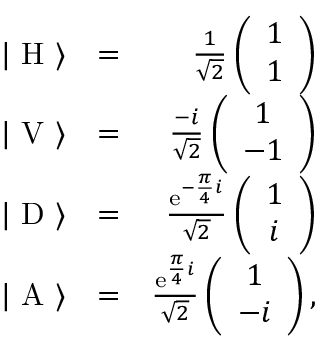Convert formula to latex. <formula><loc_0><loc_0><loc_500><loc_500>\begin{array} { r l r } { | \ H \ \rangle } & { = } & { \frac { 1 } { \sqrt { 2 } } \left ( \begin{array} { c } { 1 } \\ { 1 } \end{array} \right ) } \\ { | \ V \ \rangle } & { = } & { \frac { - i } { \sqrt { 2 } } \left ( \begin{array} { c } { 1 } \\ { - 1 } \end{array} \right ) } \\ { | \ D \ \rangle } & { = } & { \frac { e ^ { - \frac { \pi } { 4 } i } } { \sqrt { 2 } } \left ( \begin{array} { c } { 1 } \\ { i } \end{array} \right ) } \\ { | \ A \ \rangle } & { = } & { \frac { e ^ { \frac { \pi } { 4 } i } } { \sqrt { 2 } } \left ( \begin{array} { c } { 1 } \\ { - i } \end{array} \right ) , } \end{array}</formula> 